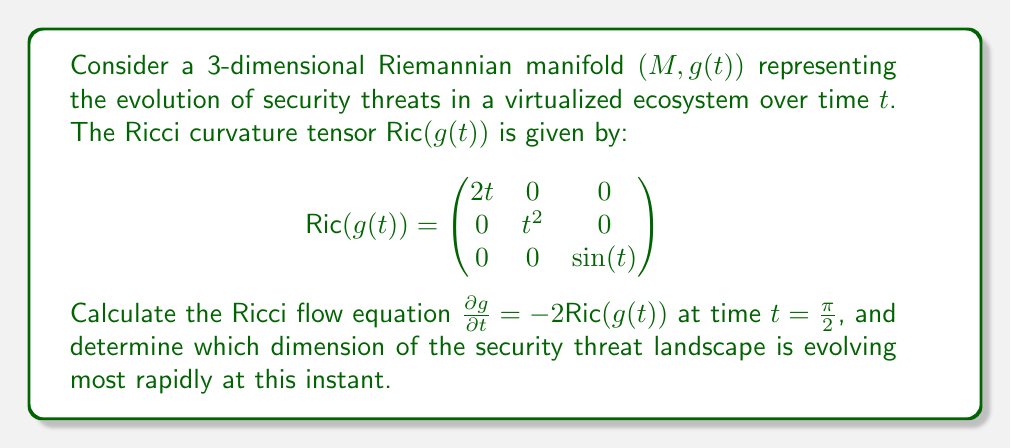Solve this math problem. To solve this problem, we'll follow these steps:

1) Recall that the Ricci flow equation is given by:

   $$\frac{\partial g}{\partial t} = -2\text{Ric}(g(t))$$

2) We need to evaluate this at $t=\frac{\pi}{2}$. First, let's calculate $\text{Ric}(g(\frac{\pi}{2}))$:

   $$\text{Ric}(g(\frac{\pi}{2})) = \begin{pmatrix}
   2(\frac{\pi}{2}) & 0 & 0 \\
   0 & (\frac{\pi}{2})^2 & 0 \\
   0 & 0 & \sin(\frac{\pi}{2})
   \end{pmatrix} = \begin{pmatrix}
   \pi & 0 & 0 \\
   0 & \frac{\pi^2}{4} & 0 \\
   0 & 0 & 1
   \end{pmatrix}$$

3) Now, we can calculate $\frac{\partial g}{\partial t}$ at $t=\frac{\pi}{2}$:

   $$\frac{\partial g}{\partial t}|_{t=\frac{\pi}{2}} = -2\text{Ric}(g(\frac{\pi}{2})) = \begin{pmatrix}
   -2\pi & 0 & 0 \\
   0 & -\frac{\pi^2}{2} & 0 \\
   0 & 0 & -2
   \end{pmatrix}$$

4) To determine which dimension is evolving most rapidly, we need to compare the absolute values of the diagonal elements:

   $|-2\pi| \approx 6.28$
   $|-\frac{\pi^2}{2}| \approx 4.93$
   $|-2| = 2$

5) The largest absolute value corresponds to the dimension evolving most rapidly.
Answer: The Ricci flow equation at $t=\frac{\pi}{2}$ is:

$$\frac{\partial g}{\partial t}|_{t=\frac{\pi}{2}} = \begin{pmatrix}
-2\pi & 0 & 0 \\
0 & -\frac{\pi^2}{2} & 0 \\
0 & 0 & -2
\end{pmatrix}$$

The first dimension (corresponding to $-2\pi$) is evolving most rapidly at this instant, indicating that this aspect of the security threat landscape is changing most quickly in the virtualized ecosystem. 